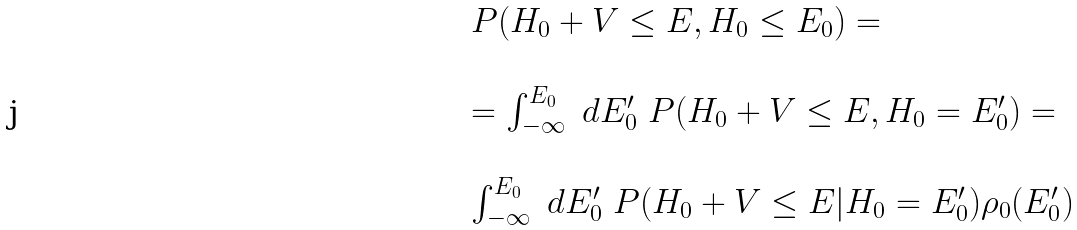Convert formula to latex. <formula><loc_0><loc_0><loc_500><loc_500>\begin{array} { l l } P ( H _ { 0 } + V \leq E , H _ { 0 } \leq E _ { 0 } ) = \\ \\ = \int _ { - \infty } ^ { E _ { 0 } } \ d E _ { 0 } ^ { \prime } \ P ( H _ { 0 } + V \leq E , H _ { 0 } = E _ { 0 } ^ { \prime } ) = \\ \\ \int _ { - \infty } ^ { E _ { 0 } } \ d E _ { 0 } ^ { \prime } \ P ( H _ { 0 } + V \leq E | H _ { 0 } = E _ { 0 } ^ { \prime } ) \rho _ { 0 } ( E _ { 0 } ^ { \prime } ) \end{array}</formula> 